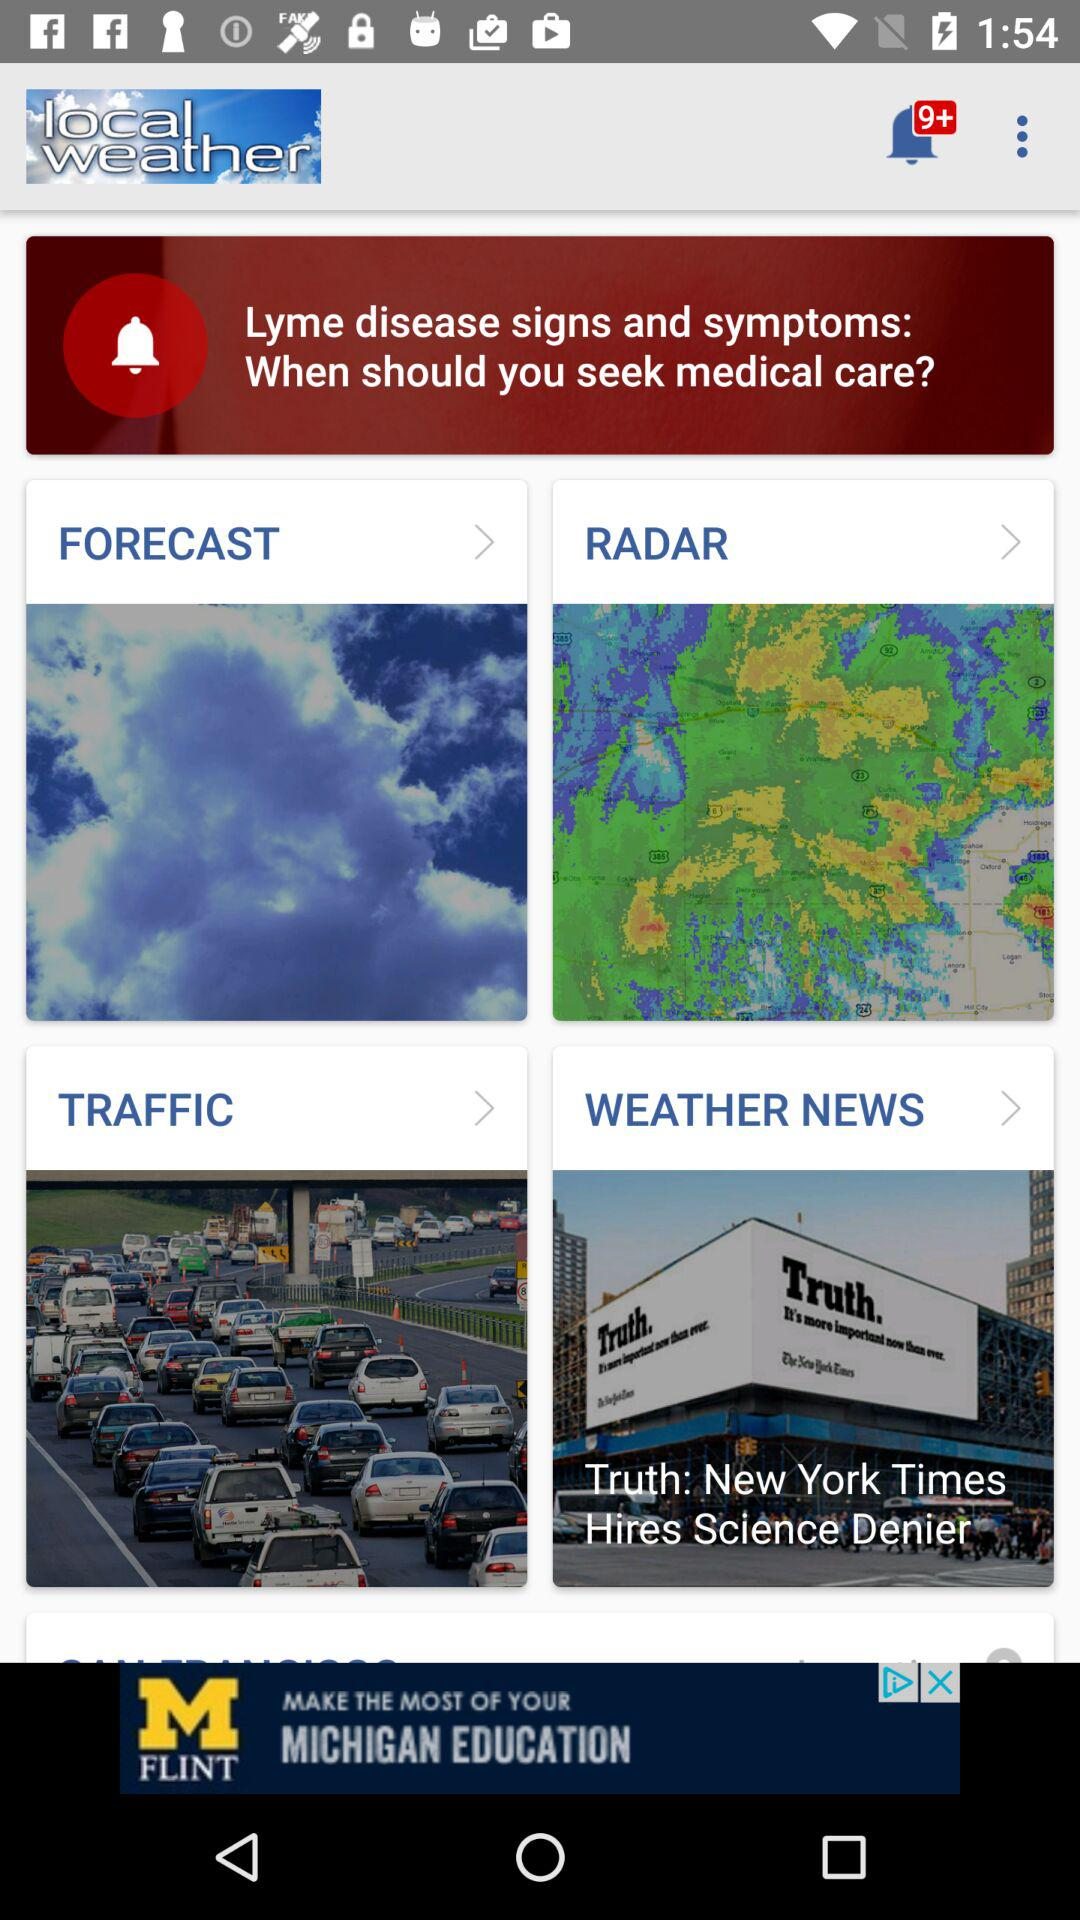How many notifications are pending? There are more than 9 pending notifications. 